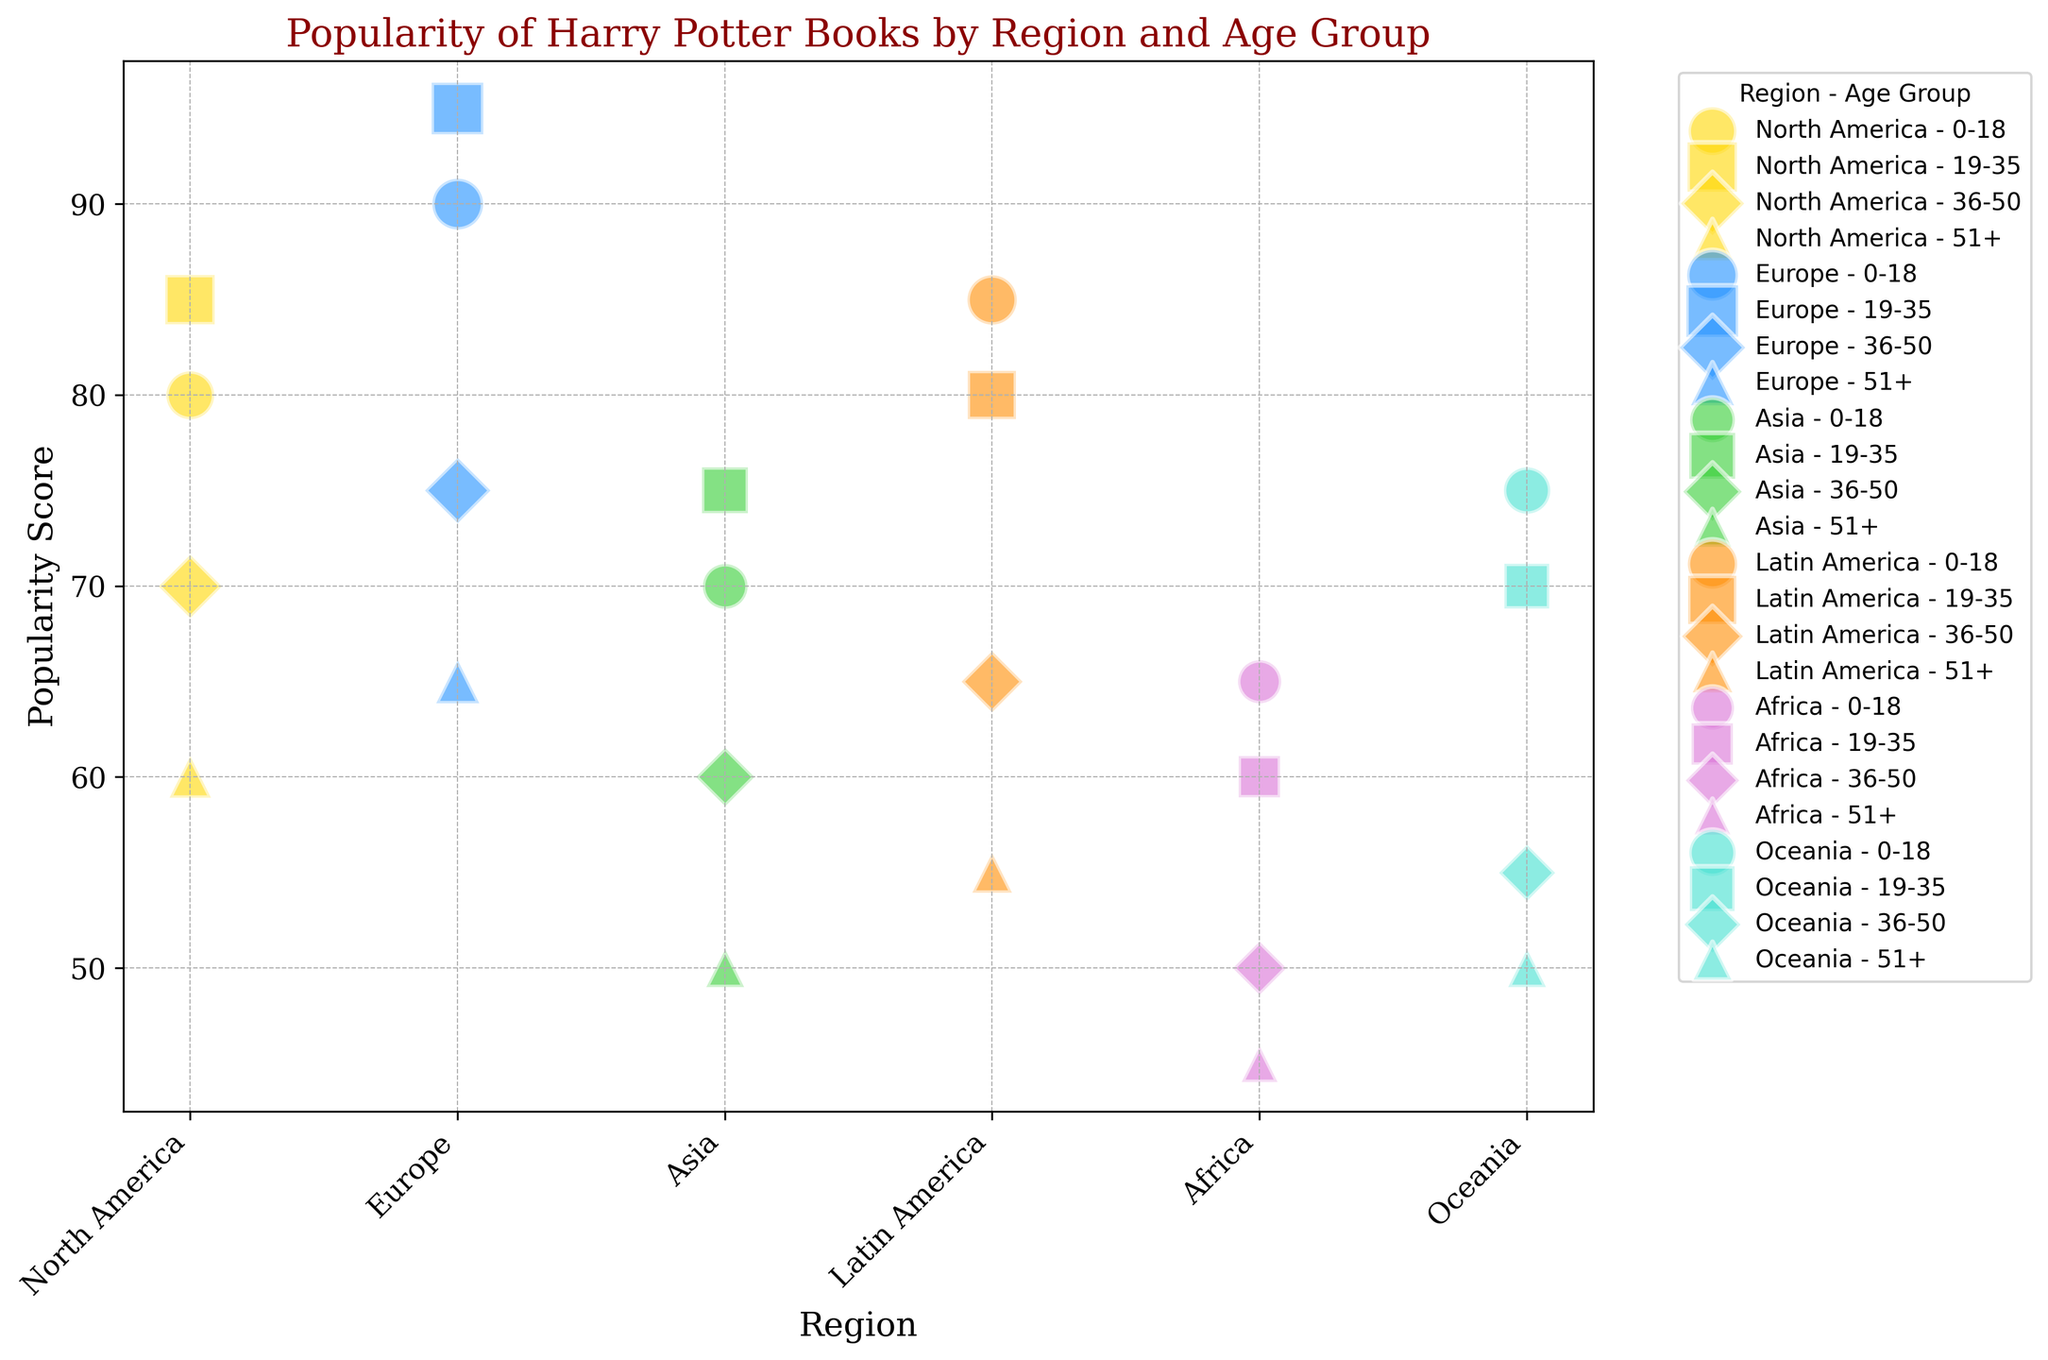Which region has the highest popularity score for the age group 19-35? First, locate the region with the age group of 19-35 on the x-axis. Compare the popularity scores. Europe has the highest score of 95.
Answer: Europe Which age group in Africa has the lowest popularity score? Look at the data points labeled Africa and identify the one with the lowest score. The age group 51+ has the lowest popularity score of 45.
Answer: 51+ What is the difference in the popularity scores of the 0-18 and 51+ age groups in North America? Find the popularity scores for the 0-18 (80) and 51+ (60) age groups in North America, then subtract the smaller from the larger: 80 - 60 = 20.
Answer: 20 In which region does the 19-35 age group have a higher popularity score than the 0-18 age group? Compare the popularity scores for the 19-35 and 0-18 age groups within each region. Europe has 95 (19-35) > 90 (0-18), and North America has 85 (19-35) > 80 (0-18). So the answer is Europe and North America.
Answer: Europe, North America Which region shows the largest bubble size for the 36-50 age group? Locate the 36-50 age group in each region and compare the bubble sizes visually. Europe has the largest bubble size of 375.
Answer: Europe What is the average popularity score across all age groups in Asia? Find the popularity scores for all age groups in Asia (70, 75, 60, 50), sum them up (70 + 75 + 60 + 50 = 255), then divide by the number of groups (4): 255 / 4 = 63.75.
Answer: 63.75 Which age group in Latin America has the highest popularity score? Among the age groups in Latin America, find the one with the highest popularity score. The 0-18 age group has the highest score of 85.
Answer: 0-18 Is the popularity score for the 0-18 age group higher in Oceania or Asia? Compare the popularity scores of the 0-18 age group in Oceania (75) and Asia (70). Oceania has a higher score.
Answer: Oceania How many regions have a popularity score of 50 or less for the age group 51+? Identify the popularity scores for the 51+ age group in all regions and count those with scores 50 or less. Asia (50) and Africa (45) meet this criterion, so it’s 2.
Answer: 2 What is the combined bubble size of the 0-18 age groups for all regions? Add the bubble sizes for all regions in the 0-18 age group: 400 (North America) + 450 (Europe) + 350 (Asia) + 425 (Latin America) + 325 (Africa) + 375 (Oceania) = 2325.
Answer: 2325 